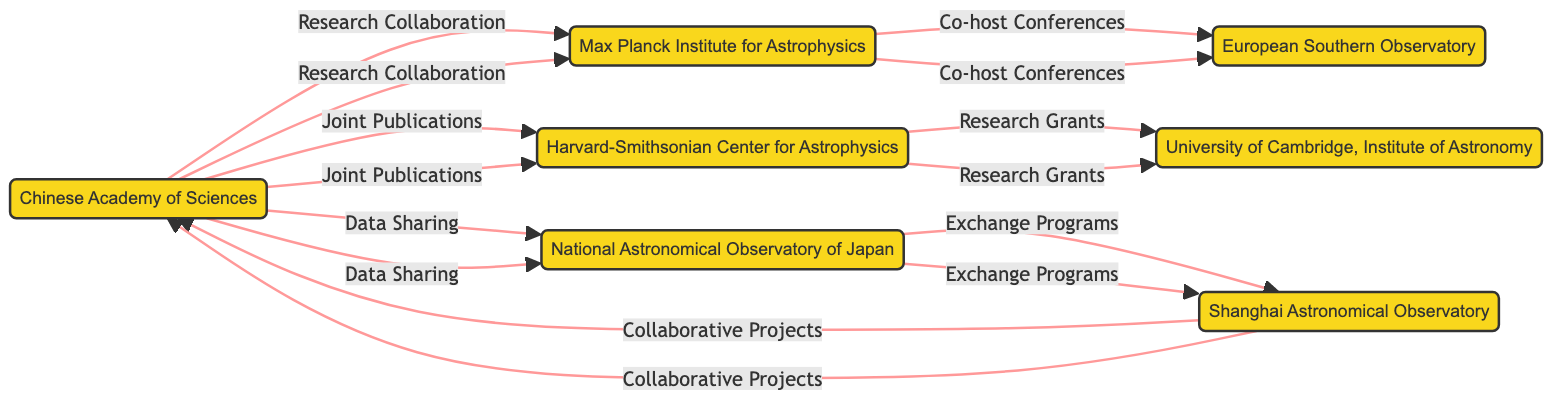What is the total number of institutions in the diagram? The diagram shows a total of 7 institutions listed as nodes, which are the Chinese Academy of Sciences, Max Planck Institute for Astrophysics, Harvard-Smithsonian Center for Astrophysics, National Astronomical Observatory of Japan, European Southern Observatory, Shanghai Astronomical Observatory, and University of Cambridge, Institute of Astronomy.
Answer: 7 Which institution is linked to both research collaboration and joint publications? The Chinese Academy of Sciences is the only institution that is connected to both the Max Planck Institute for Astrophysics through research collaboration and the Harvard-Smithsonian Center for Astrophysics through joint publications.
Answer: Chinese Academy of Sciences Name an institution that has a connection to collaborative projects. The Shanghai Astronomical Observatory has a direct connection to collaborative projects, as indicated in the diagram where it links back to the Chinese Academy of Sciences.
Answer: Shanghai Astronomical Observatory What type of connection exists between the Max Planck Institute for Astrophysics and the European Southern Observatory? The connection between the Max Planck Institute for Astrophysics and the European Southern Observatory is classified as "Co-host Conferences," which indicates a collaborative effort in organizing conferences together.
Answer: Co-host Conferences Which institution is involved in research grants? The University of Cambridge, Institute of Astronomy is involved in research grants, as indicated by the directed edge from the Harvard-Smithsonian Center for Astrophysics to it.
Answer: University of Cambridge, Institute of Astronomy How many distinct types of connections are illustrated in the diagram? The diagram illustrates 6 distinct types of connections: Research Collaboration, Joint Publications, Data Sharing, Co-host Conferences, Research Grants, and Exchange Programs.
Answer: 6 Can you name a connection that indicates data sharing? The connection indicating data sharing is between the Chinese Academy of Sciences and the National Astronomical Observatory of Japan, showing collaboration in data sharing efforts.
Answer: Data Sharing What is the nature of the relationship between the Shanghai Astronomical Observatory and the Chinese Academy of Sciences? The relationship between the Shanghai Astronomical Observatory and the Chinese Academy of Sciences is through collaborative projects, indicating a direct collaborative activity.
Answer: Collaborative Projects 